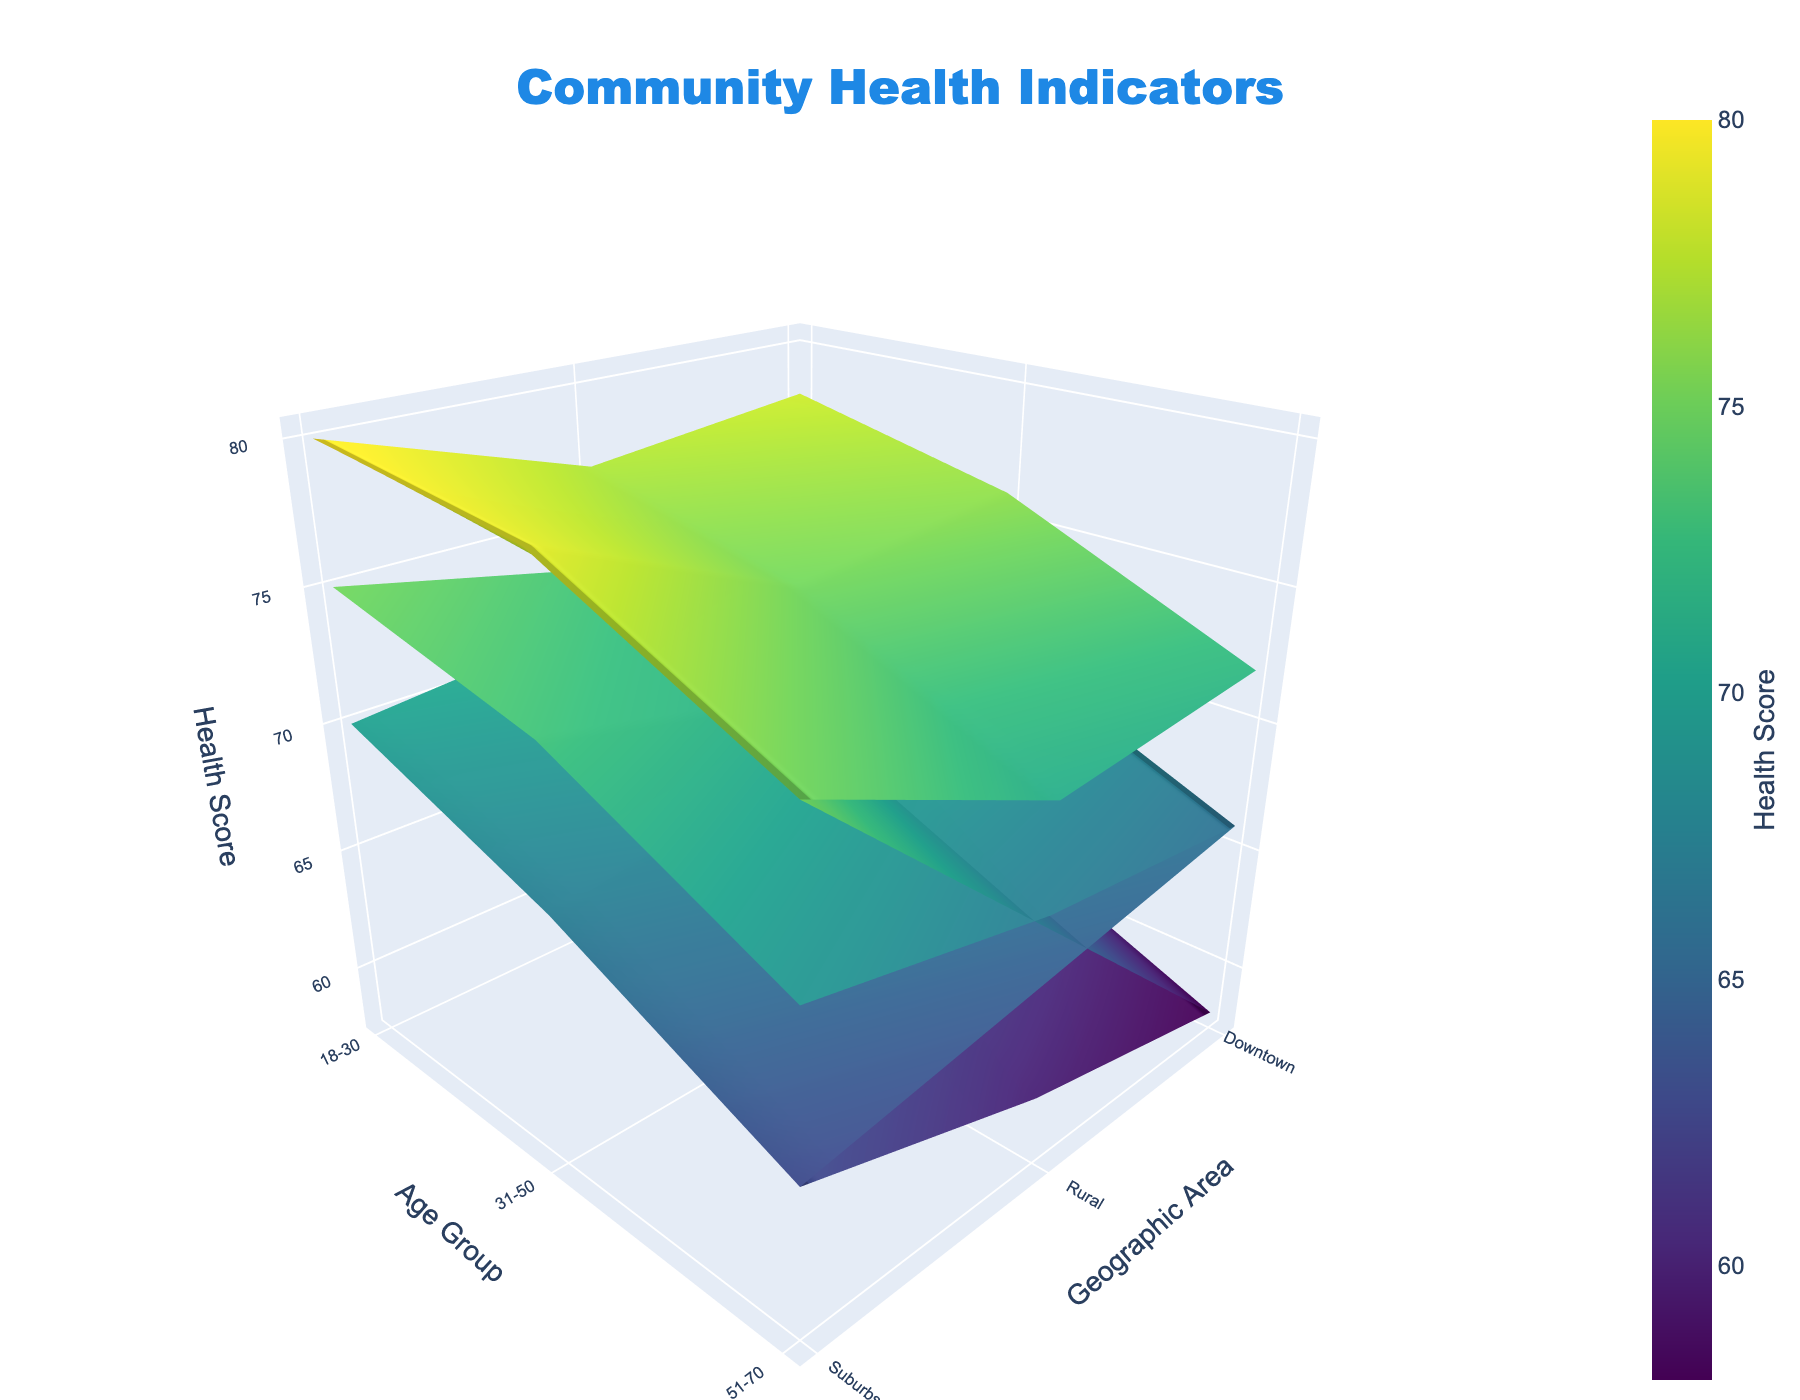What is the title of the 3D surface plot? The title of the plot is at the top center and it reads "Community Health Indicators."
Answer: Community Health Indicators What is the health score for the 31-50 age group in the downtown area with a high income level? Look for the 31-50 age group in the downtown area under the high-income level quadrant; the health score at this intersection on the surface plot is noted.
Answer: 76 Between which age groups do you see the highest variation in health scores? By comparing the vertical differences in the z-axis between different age groups across all geographic areas and income levels, the variation is the most pronounced between 18-30 and 51-70 age groups.
Answer: 18-30 and 51-70 What trend do you observe in health scores as income level increases for the 51-70 age group in the suburbs area? Analyze the health scores for the 51-70 age group across different income levels in the suburbs; the trend shows health scores increasing as income level goes up.
Answer: Increases Which geographic area has the lowest health score for the 31-50 age group with a low income level? Identify the 31-50 age group with a low income level and then compare the health scores for different geographic areas; the downtown area has the lowest health score.
Answer: Downtown On average, how do health scores in rural areas compare to those in downtown areas for all age groups and income levels? Calculate the average health scores for rural areas and downtown areas across all age groups and income levels, then compare the two averages.
Answer: Rural areas have slightly higher average health scores compared to downtown areas Which age group has the highest health score in the suburbs for a high income level? Focus on the suburbs area with a high income level and compare the health scores among different age groups; the 18-30 age group has the highest health score.
Answer: 18-30 Does the health score increase more with income level or with age group changes? Compare the variations in health scores with respect to changes in income levels and age groups across the same geographic area; health scores increase more significantly with changes in income levels.
Answer: Income level What is the average health score for medium income level across all age groups and geographic areas? Sum the health scores for the medium income level across all age groups and geographic areas, then divide by the number of data points.
Answer: 71.7 